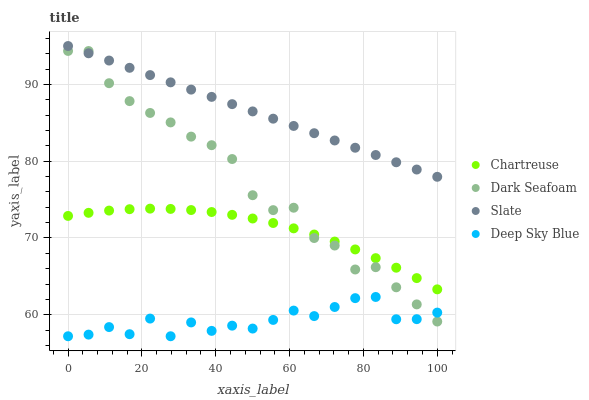Does Deep Sky Blue have the minimum area under the curve?
Answer yes or no. Yes. Does Slate have the maximum area under the curve?
Answer yes or no. Yes. Does Dark Seafoam have the minimum area under the curve?
Answer yes or no. No. Does Dark Seafoam have the maximum area under the curve?
Answer yes or no. No. Is Slate the smoothest?
Answer yes or no. Yes. Is Dark Seafoam the roughest?
Answer yes or no. Yes. Is Dark Seafoam the smoothest?
Answer yes or no. No. Is Slate the roughest?
Answer yes or no. No. Does Deep Sky Blue have the lowest value?
Answer yes or no. Yes. Does Dark Seafoam have the lowest value?
Answer yes or no. No. Does Slate have the highest value?
Answer yes or no. Yes. Does Dark Seafoam have the highest value?
Answer yes or no. No. Is Deep Sky Blue less than Slate?
Answer yes or no. Yes. Is Slate greater than Chartreuse?
Answer yes or no. Yes. Does Dark Seafoam intersect Chartreuse?
Answer yes or no. Yes. Is Dark Seafoam less than Chartreuse?
Answer yes or no. No. Is Dark Seafoam greater than Chartreuse?
Answer yes or no. No. Does Deep Sky Blue intersect Slate?
Answer yes or no. No. 